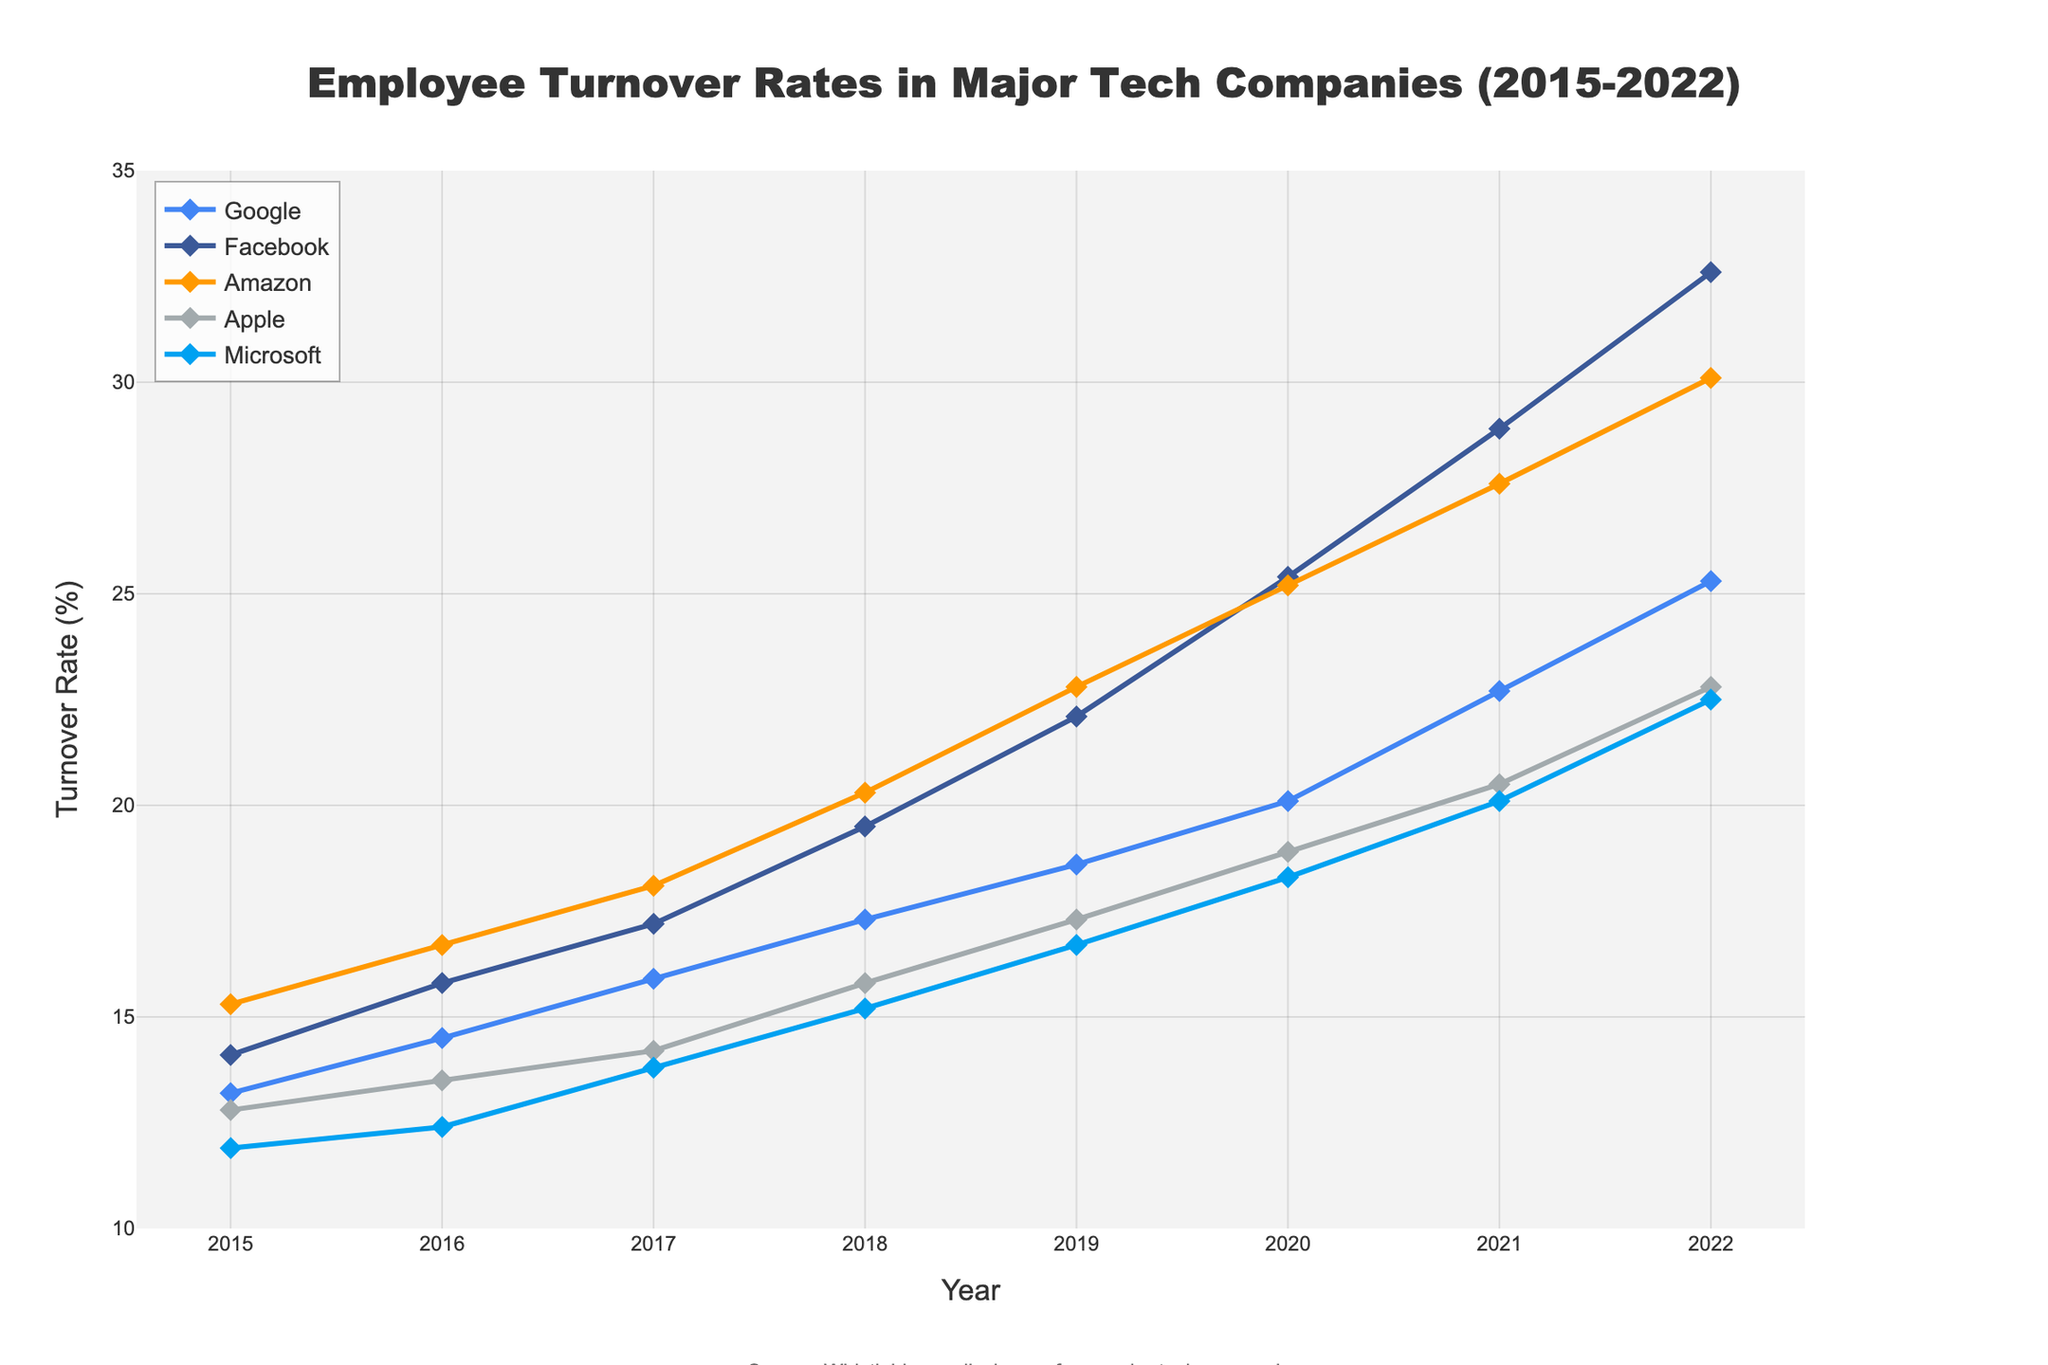what is the overall trend in employee turnover rates from 2015 to 2022 across all companies? The overall trend shows an increasing rate of employee turnover for all five companies (Google, Facebook, Amazon, Apple, Microsoft) from 2015 to 2022. This can be seen as a general upward movement of each line in the chart.
Answer: Increasing Which company had the highest turnover rate in 2022? By looking at the line chart for the year 2022, Facebook's (with a navy blue line) turnover rate is the highest among all the companies.
Answer: Facebook Which company had the lowest turnover rate in 2015? In the year 2015, the company with the lowest turnover rate is Microsoft, represented by the light blue line.
Answer: Microsoft By how much did Amazon's employee turnover rate increase from 2015 to 2022? Amazon's turnover rate in 2015 was 15.3%, and it increased to 30.1% in 2022. The difference is 30.1 - 15.3 = 14.8.
Answer: 14.8% What is the average turnover rate of Apple over the given years? Add up the turnover rates of Apple from 2015 to 2022 and divide by the number of years: (12.8 + 13.5 + 14.2 + 15.8 + 17.3 + 18.9 + 20.5 + 22.8) / 8 = 16.97.
Answer: 16.97% Which company saw the most significant increase in turnover rate between 2019 and 2020? Subtract the 2019 turnover rate from the 2020 turnover rate for each company and identify the highest difference. Facebook (25.4 - 22.1 = 3.3) had the most significant increase.
Answer: Facebook What is the percentage point difference between the turnover rates of Google and Apple in the year 2021? In 2021, Google's turnover rate was 22.7% and Apple's was 20.5%. The difference is 22.7 - 20.5 = 2.2 percentage points.
Answer: 2.2 Which year shows the most considerable jump in turnover rate for Microsoft? By examining the chart, the most significant increase in turnover rate for Microsoft occurs between 2021 and 2022, from 20.1 to 22.5, which is an increase of 2.4 percentage points.
Answer: Between 2021 and 2022 During which year did Google’s turnover rate surpass 20% for the first time? Google surpassed a 20% turnover rate in the year 2020.
Answer: 2020 